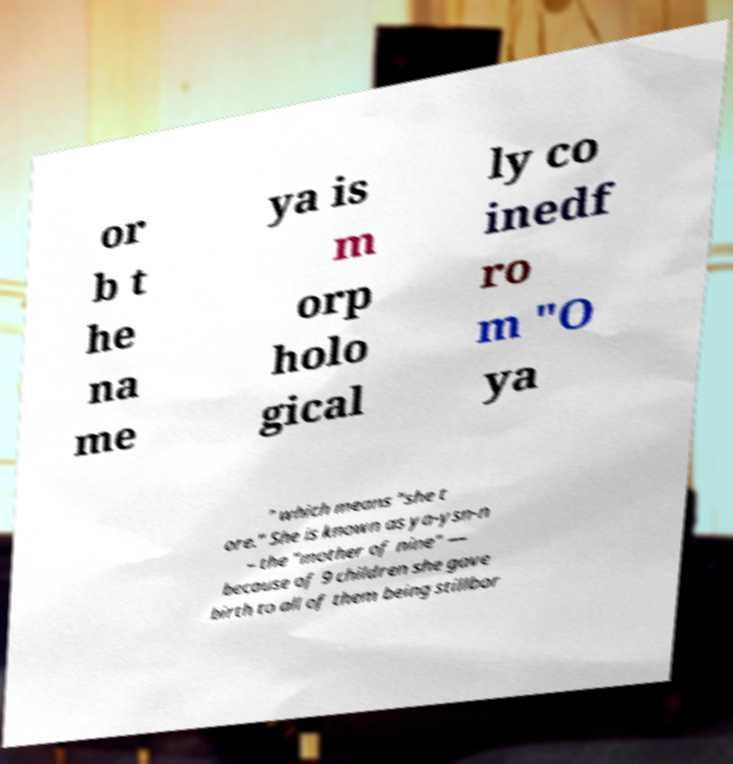Please identify and transcribe the text found in this image. or b t he na me ya is m orp holo gical ly co inedf ro m "O ya " which means "she t ore." She is known as ya-ysn-n – the "mother of nine" — because of 9 children she gave birth to all of them being stillbor 